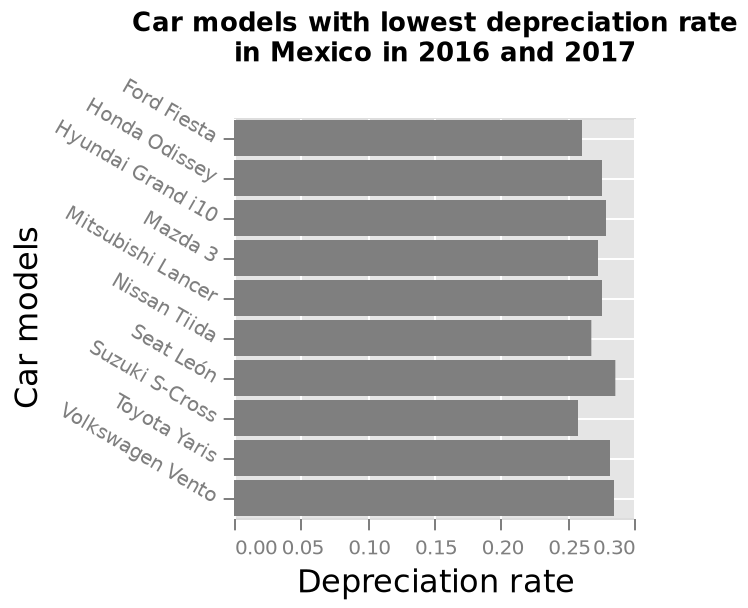<image>
Which car models have the highest depreciation rate in Mexico between 2016 and 2017? The Seat Leon and Volkswagen Vento have the highest depreciation rate in Mexico between 2016 and 2017. 